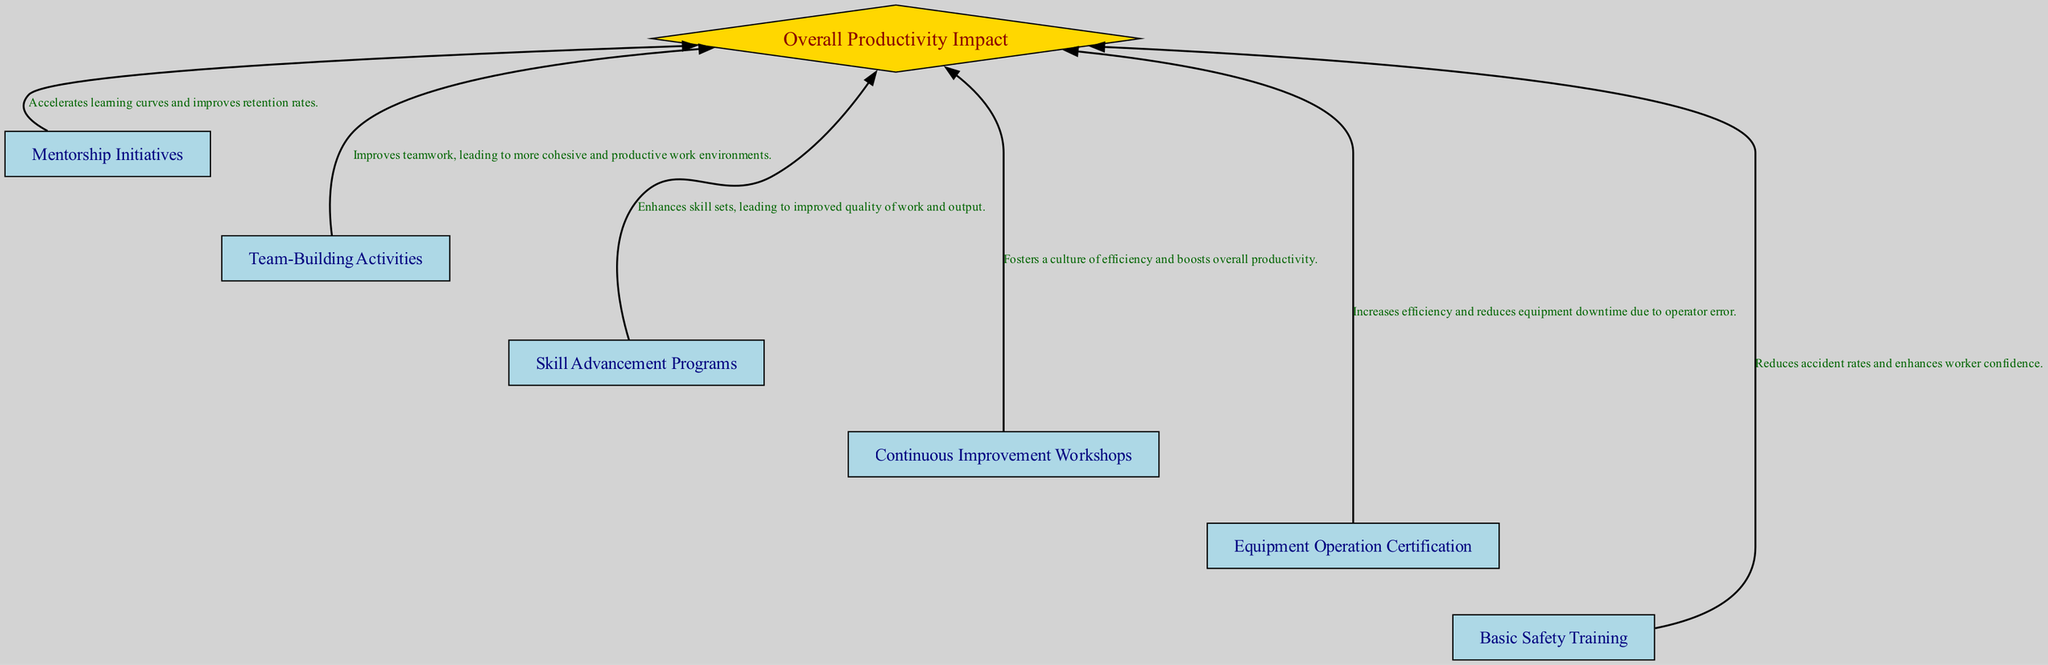What are the elements listed in the diagram? The diagram includes various training programs such as Basic Safety Training, Equipment Operation Certification, Continuous Improvement Workshops, Skill Advancement Programs, Team-Building Activities, and Mentorship Initiatives.
Answer: Basic Safety Training, Equipment Operation Certification, Continuous Improvement Workshops, Skill Advancement Programs, Team-Building Activities, Mentorship Initiatives How many training programs are shown? The diagram lists a total of six training programs, which are each represented as nodes in the flow chart.
Answer: Six What is the impact of the Basic Safety Training? The description shows that Basic Safety Training reduces accident rates and enhances worker confidence, and this information is directly linked to the specific training program node in the diagram.
Answer: Reduces accident rates and enhances worker confidence Which program has the greatest impact on overall productivity? The diagram indicates that all programs connect to the central node "Overall Productivity Impact," depicting that each has an influence, but the diagram does not assign a specific greater impact to any single program.
Answer: All programs contribute equally How many edges connect the training programs to the central impact node? Each of the six programs is connected via a directed edge to the central impact node, resulting in a total of six edges in the diagram.
Answer: Six What is the purpose of the Team-Building Activities? The diagram describes Team-Building Activities as initiatives aimed at improving teamwork, leading to more cohesive and productive work environments, which directly provides the functional aspect of this program.
Answer: Improves teamwork, leading to cohesive and productive work environments What does the overall impact node represent? The central node named "Overall Productivity Impact" represents the cumulative effect of all training programs on productivity, which is the focal point of the diagram.
Answer: Overall effect on productivity Which training program aims to enhance skill sets? The diagram clearly identifies Skill Advancement Programs as the program focused on enhancing employees' skill sets leading to improved quality of work and output, shown near the corresponding node.
Answer: Skill Advancement Programs What is the relationship between Continuous Improvement Workshops and productivity? Continuous Improvement Workshops facilitate a culture of efficiency according to the diagram and thus have a positive relationship with boosting overall productivity, as indicated by the described impact.
Answer: Fosters a culture of efficiency, boosts overall productivity 